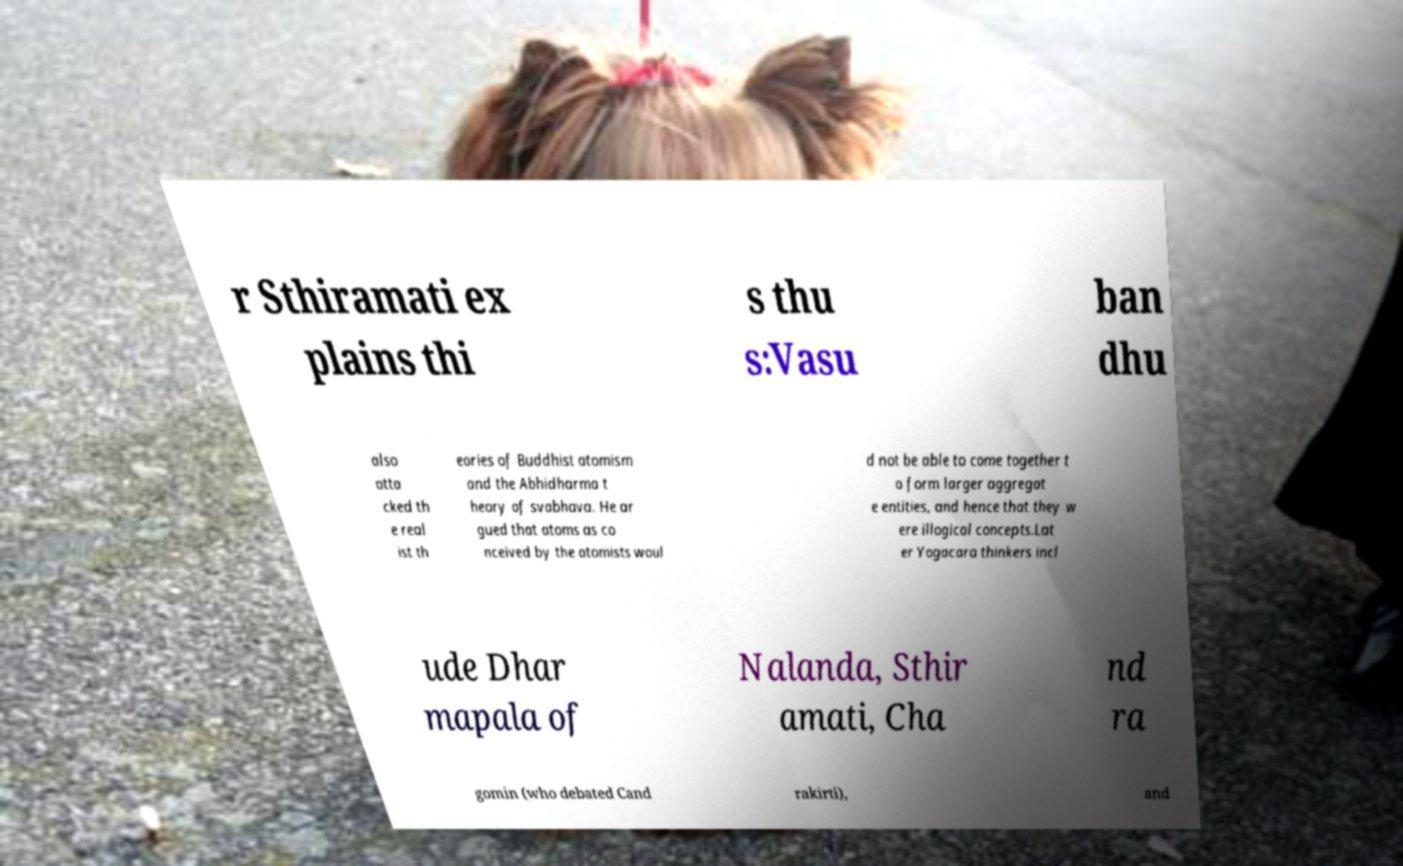Could you extract and type out the text from this image? r Sthiramati ex plains thi s thu s:Vasu ban dhu also atta cked th e real ist th eories of Buddhist atomism and the Abhidharma t heory of svabhava. He ar gued that atoms as co nceived by the atomists woul d not be able to come together t o form larger aggregat e entities, and hence that they w ere illogical concepts.Lat er Yogacara thinkers incl ude Dhar mapala of Nalanda, Sthir amati, Cha nd ra gomin (who debated Cand rakirti), and 